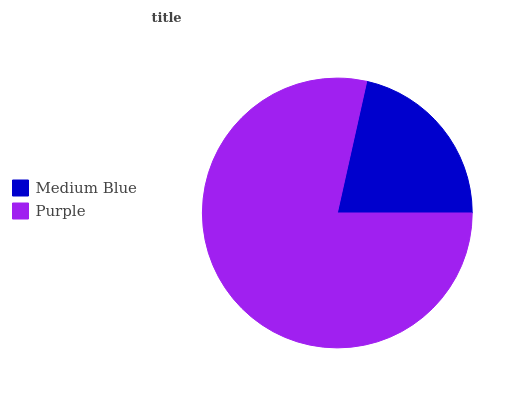Is Medium Blue the minimum?
Answer yes or no. Yes. Is Purple the maximum?
Answer yes or no. Yes. Is Purple the minimum?
Answer yes or no. No. Is Purple greater than Medium Blue?
Answer yes or no. Yes. Is Medium Blue less than Purple?
Answer yes or no. Yes. Is Medium Blue greater than Purple?
Answer yes or no. No. Is Purple less than Medium Blue?
Answer yes or no. No. Is Purple the high median?
Answer yes or no. Yes. Is Medium Blue the low median?
Answer yes or no. Yes. Is Medium Blue the high median?
Answer yes or no. No. Is Purple the low median?
Answer yes or no. No. 